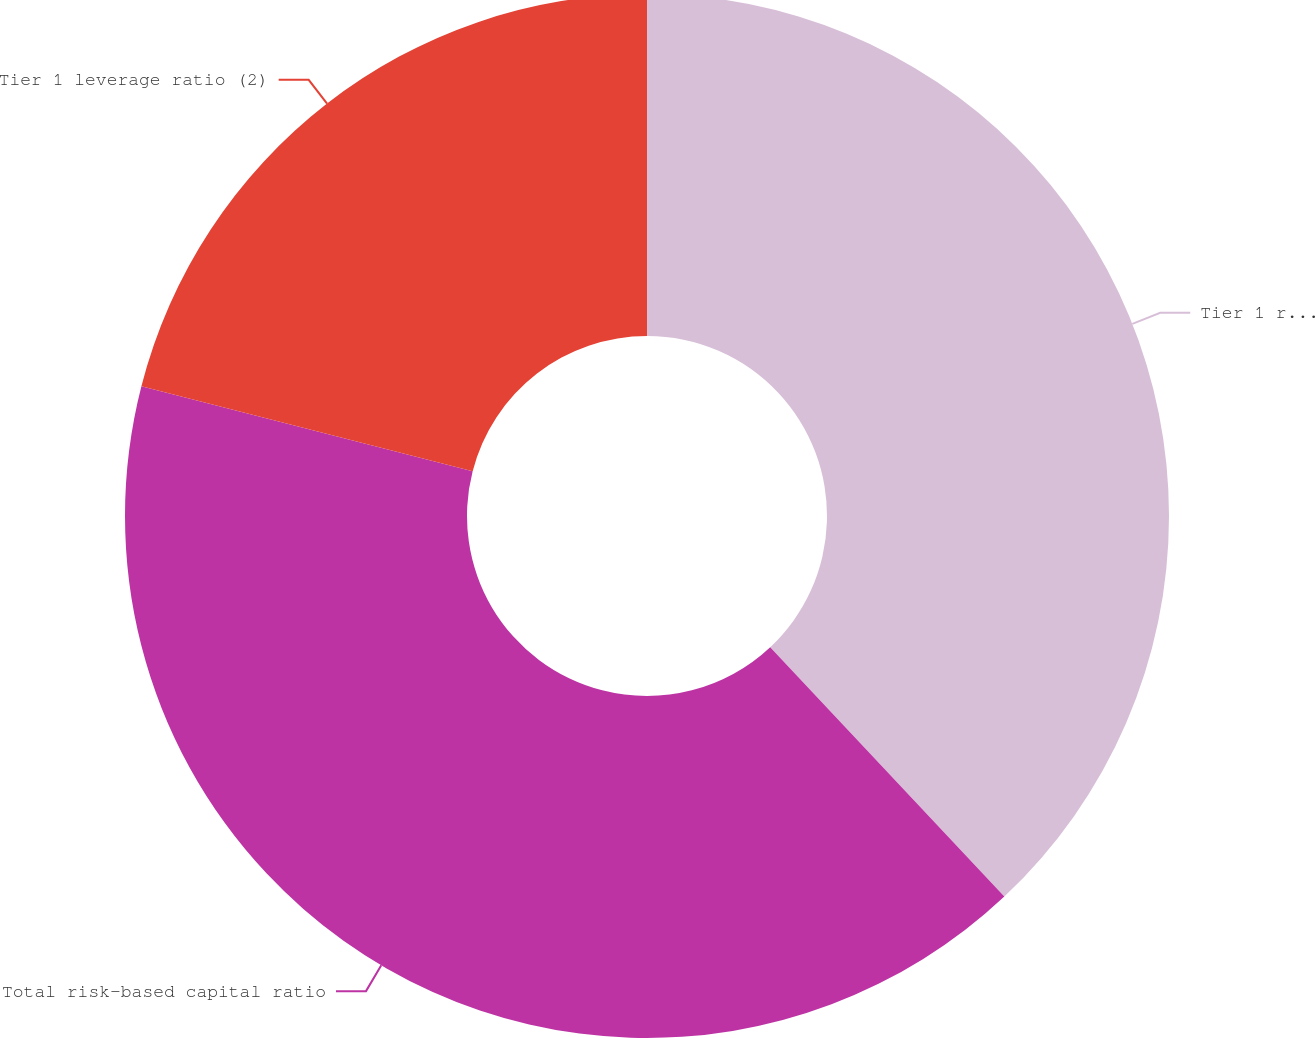Convert chart. <chart><loc_0><loc_0><loc_500><loc_500><pie_chart><fcel>Tier 1 risk-based capital<fcel>Total risk-based capital ratio<fcel>Tier 1 leverage ratio (2)<nl><fcel>38.0%<fcel>41.0%<fcel>21.0%<nl></chart> 